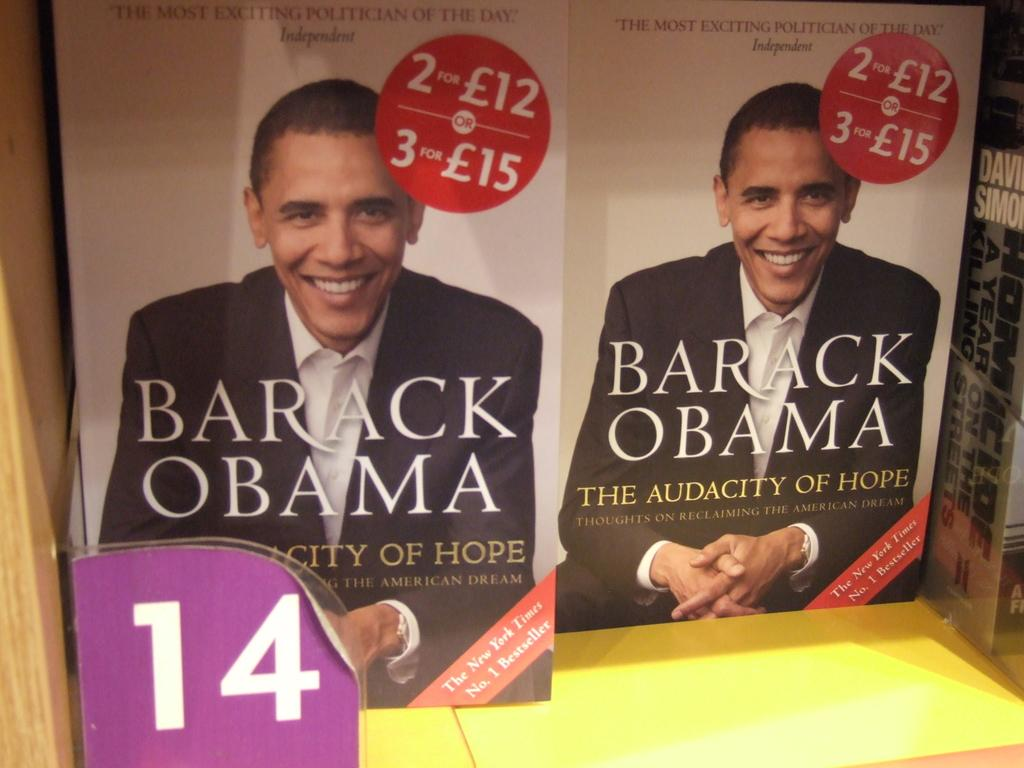<image>
Present a compact description of the photo's key features. Two books called Barack Obama are on sale on a book shelf. 